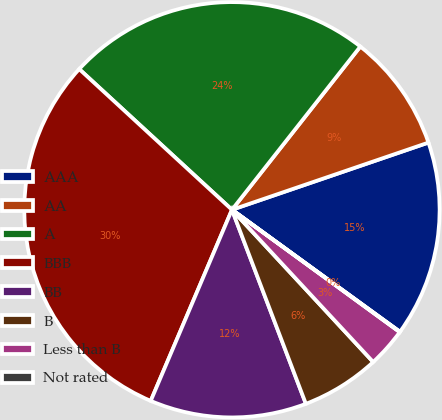Convert chart to OTSL. <chart><loc_0><loc_0><loc_500><loc_500><pie_chart><fcel>AAA<fcel>AA<fcel>A<fcel>BBB<fcel>BB<fcel>B<fcel>Less than B<fcel>Not rated<nl><fcel>15.24%<fcel>9.15%<fcel>23.76%<fcel>30.45%<fcel>12.19%<fcel>6.11%<fcel>3.07%<fcel>0.03%<nl></chart> 